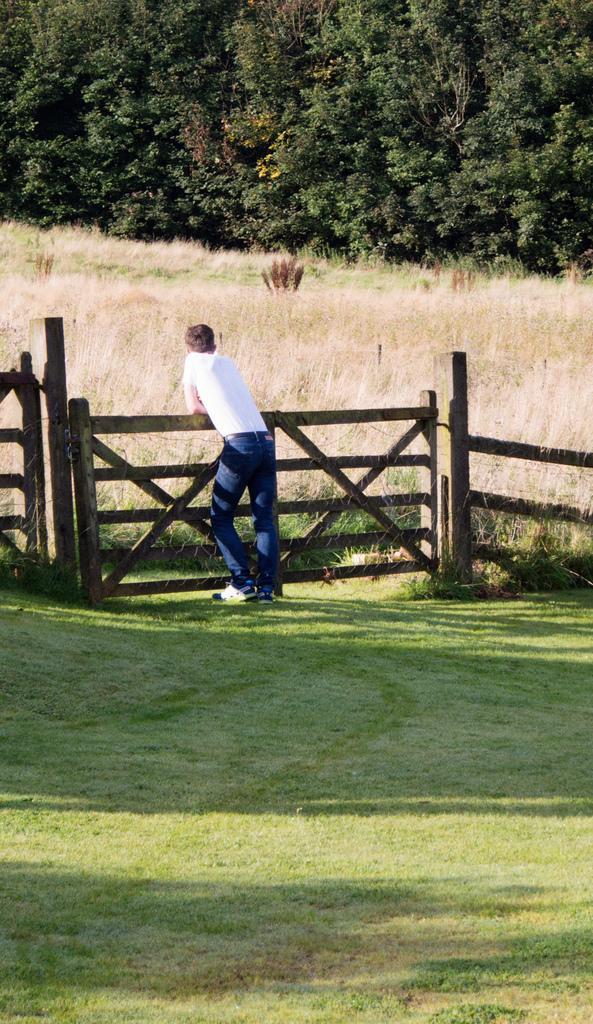Describe this image in one or two sentences. In this image we can see a person is standing on the grass at the fence. In the background we can see grass and trees. 